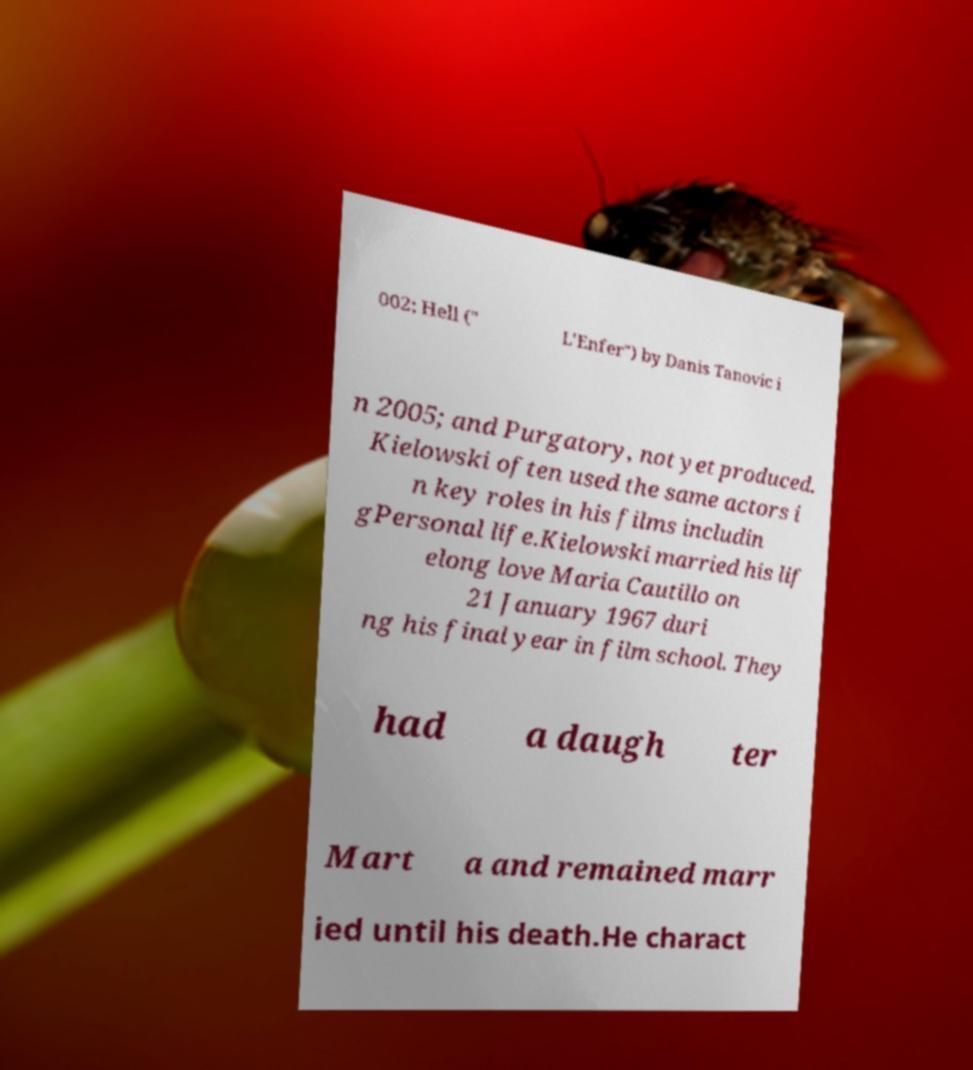There's text embedded in this image that I need extracted. Can you transcribe it verbatim? 002; Hell (" L'Enfer") by Danis Tanovic i n 2005; and Purgatory, not yet produced. Kielowski often used the same actors i n key roles in his films includin gPersonal life.Kielowski married his lif elong love Maria Cautillo on 21 January 1967 duri ng his final year in film school. They had a daugh ter Mart a and remained marr ied until his death.He charact 